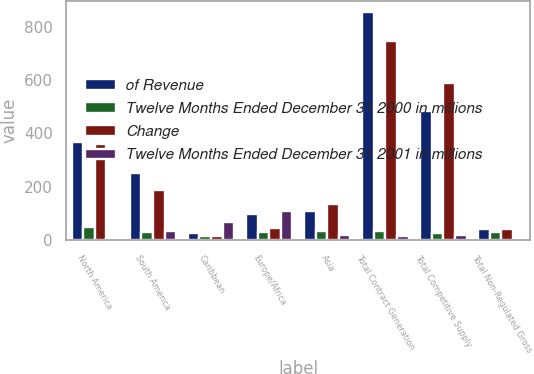Convert chart to OTSL. <chart><loc_0><loc_0><loc_500><loc_500><stacked_bar_chart><ecel><fcel>North America<fcel>South America<fcel>Caribbean<fcel>Europe/Africa<fcel>Asia<fcel>Total Contract Generation<fcel>Total Competitive Supply<fcel>Total Non-Regulated Gross<nl><fcel>of Revenue<fcel>368<fcel>253<fcel>27<fcel>96<fcel>110<fcel>854<fcel>484<fcel>40.5<nl><fcel>Twelve Months Ended December 31 2000 in millions<fcel>50<fcel>31<fcel>13<fcel>29<fcel>33<fcel>35<fcel>25<fcel>30<nl><fcel>Change<fcel>360<fcel>189<fcel>16<fcel>46<fcel>136<fcel>747<fcel>588<fcel>40.5<nl><fcel>Twelve Months Ended December 31 2001 in millions<fcel>2<fcel>34<fcel>69<fcel>109<fcel>19<fcel>14<fcel>18<fcel>0<nl></chart> 